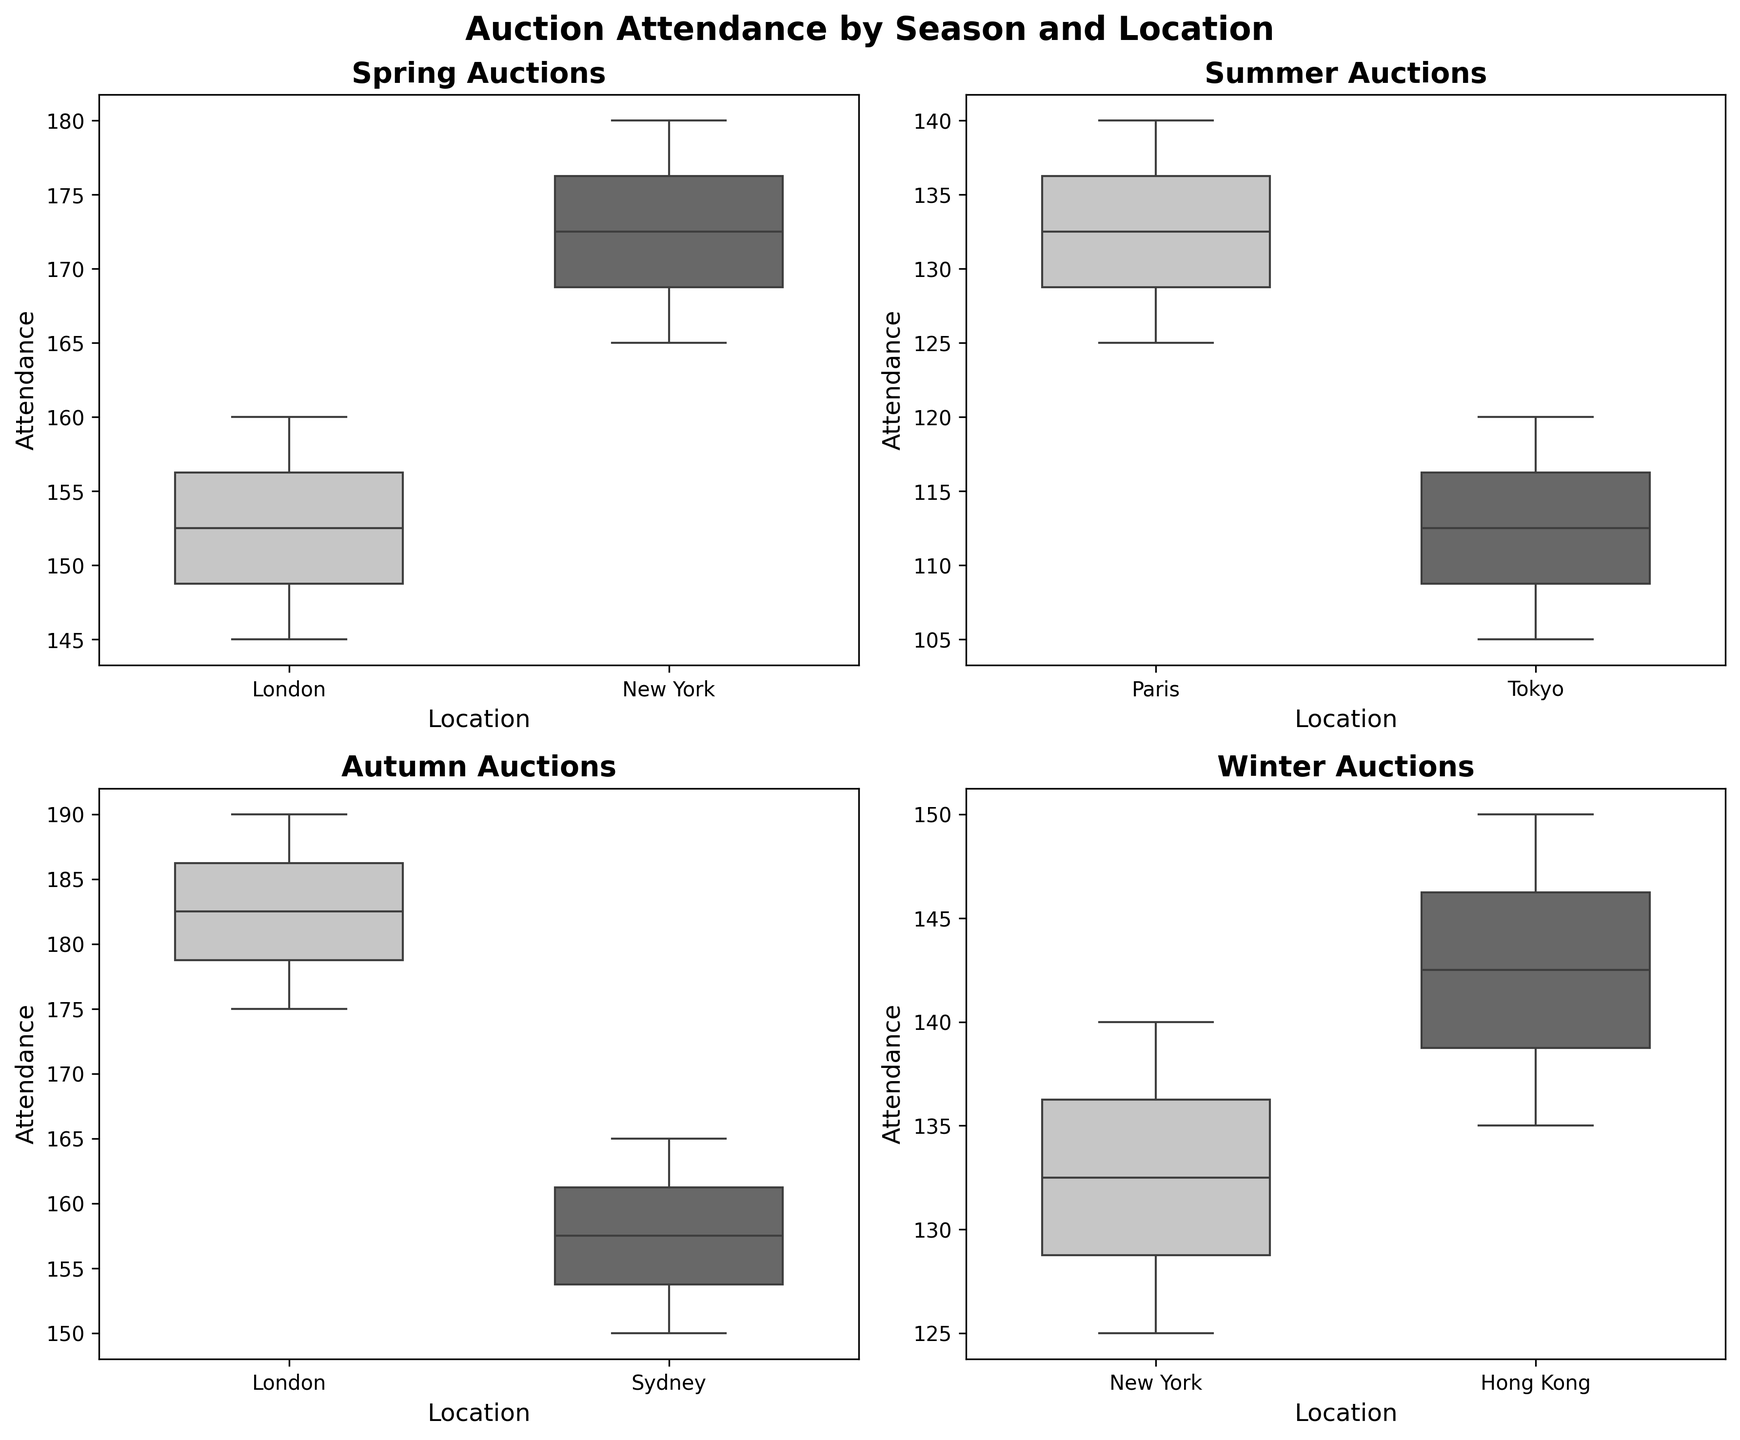How many seasons are represented in the figure? The figure contains four subplots, each representing a different season. The titles of each subplot list "Spring," "Summer," "Autumn," and "Winter."
Answer: Four Which location has the highest median attendance in Spring auctions? In the Spring subplot, both London and New York are shown. The median line in the box plot for New York is higher than that for London.
Answer: New York Compare the range of attendance in Summer auctions between Paris and Tokyo. Which one is larger? In the Summer subplot, the range from the minimum to maximum values for Paris is larger than that for Tokyo. Specifically, Paris ranges from 125 to 140, while Tokyo ranges from 105 to 120, making Paris's range larger.
Answer: Paris What is the approximate interquartile range (IQR) for London auctions in Autumn? The IQR is the range between the first quartile (Q1) and the third quartile (Q3). For London in the Autumn subplot, Q1 is around 180 and Q3 is around 185. The IQR is 185 - 180 = 5.
Answer: 5 How does the attendance variability in Winter auctions in New York compare to Hong Kong? Looking at the Winter subplot, the box plot for New York is more spread out compared to that for Hong Kong. This indicates higher variability in attendance in New York compared to Hong Kong.
Answer: New York has higher variability From a visual inspection, which season seems to have the lowest median attendance overall? The medians of the box plots for each season are compared. The Summer subplot shows lower medians for both Paris and Tokyo compared to other seasons, indicating the lowest median attendance.
Answer: Summer Which location has the smallest fluctuation in attendance during the Spring auctions? In the Spring subplot, London has a smaller range (from approximately 145 to 160) when compared to New York (from approximately 165 to 180), indicating smaller fluctuation.
Answer: London What are the maximum attendance values for Spring and Autumn in London? By checking the box plots for London in both Spring and Autumn, the maximum values are around 160 in Spring and 190 in Autumn.
Answer: 160 in Spring, 190 in Autumn Is there any location where the median attendance in Winter exceeds that of Summer? By comparing the median lines in the Winter and Summer subplots, the median attendance in Winter for both New York and Hong Kong exceeds those for Paris and Tokyo in Summer.
Answer: Yes Identify the season and location with the tightest clustering of attendance figures. Tightest clustering means the smallest range from Q1 to Q3. By inspecting the subplots, Autumn in Sydney has the smallest range roughly between 150 and 160.
Answer: Autumn, Sydney 